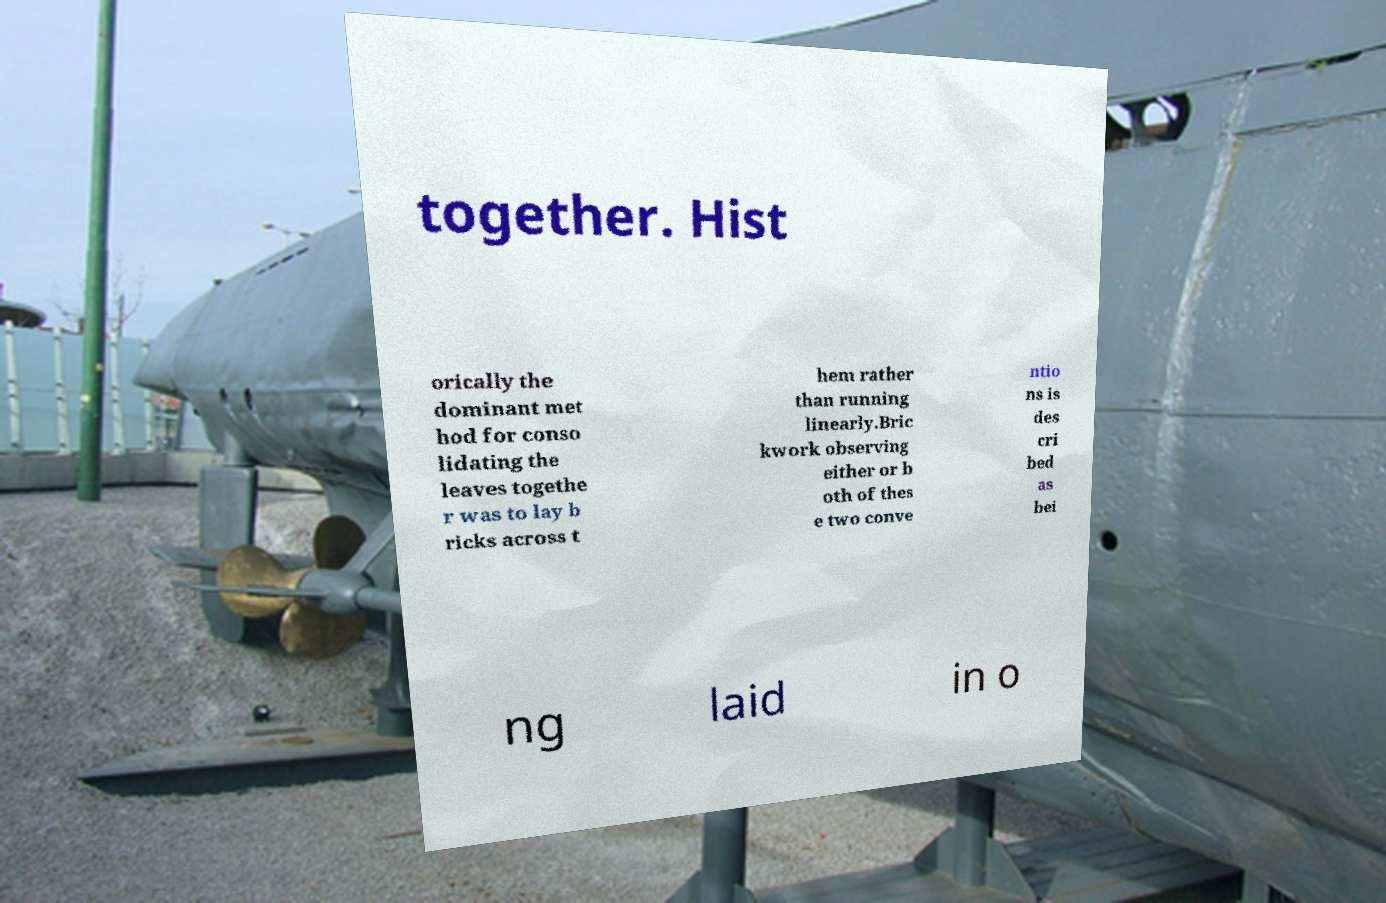I need the written content from this picture converted into text. Can you do that? together. Hist orically the dominant met hod for conso lidating the leaves togethe r was to lay b ricks across t hem rather than running linearly.Bric kwork observing either or b oth of thes e two conve ntio ns is des cri bed as bei ng laid in o 